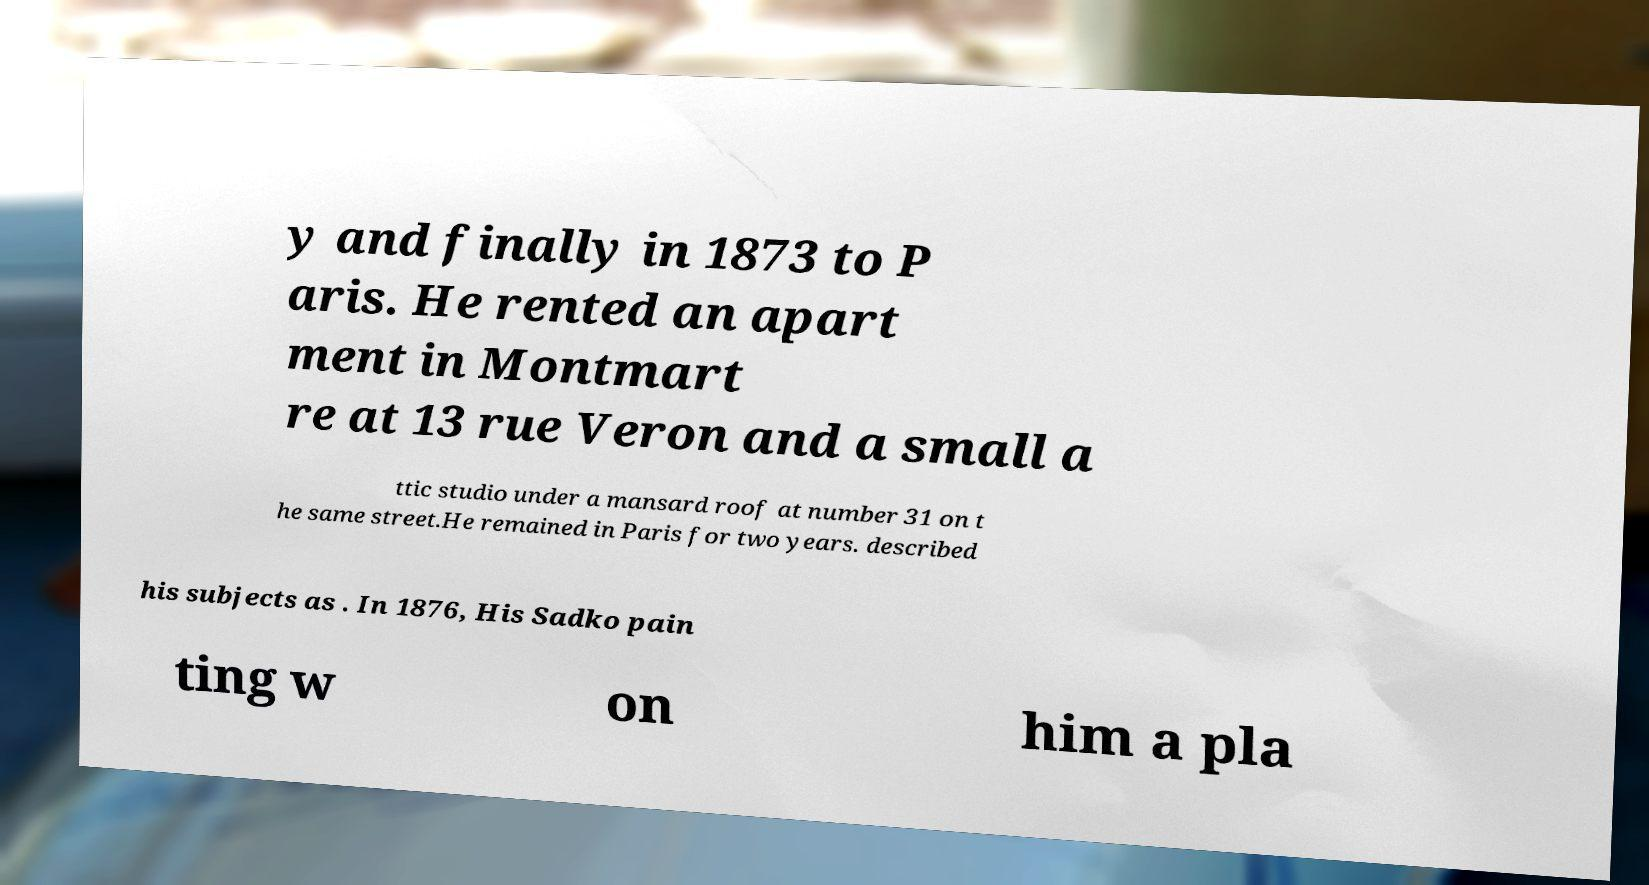Could you extract and type out the text from this image? y and finally in 1873 to P aris. He rented an apart ment in Montmart re at 13 rue Veron and a small a ttic studio under a mansard roof at number 31 on t he same street.He remained in Paris for two years. described his subjects as . In 1876, His Sadko pain ting w on him a pla 